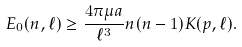Convert formula to latex. <formula><loc_0><loc_0><loc_500><loc_500>E _ { 0 } ( n , \ell ) \geq \frac { 4 \pi \mu a } { \ell ^ { 3 } } n ( n - 1 ) K ( p , \ell ) .</formula> 